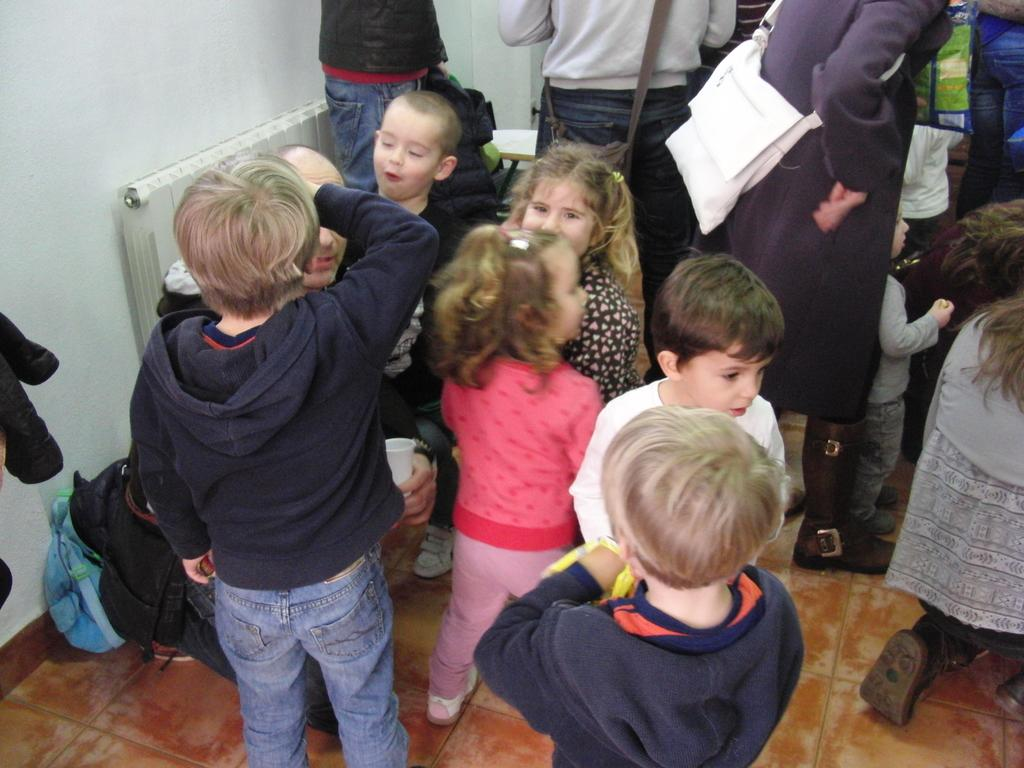Who is present in the image? There are people in the image, including kids. What can be seen on the left side of the image? There is a wall on the left side of the image. What is the other main object in the image? There is a board in the image. What type of sail can be seen on the board in the image? There is no sail present on the board in the image. In which country is the image taken? The provided facts do not give any information about the country where the image was taken. 